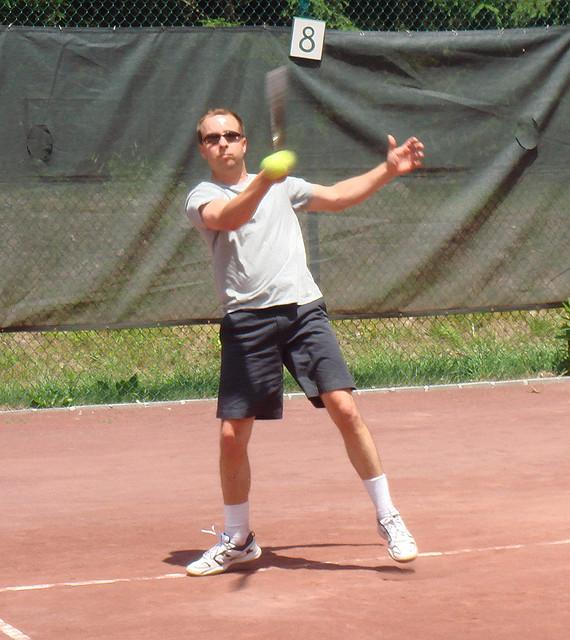Why is the man wearing glasses? block sunlight 